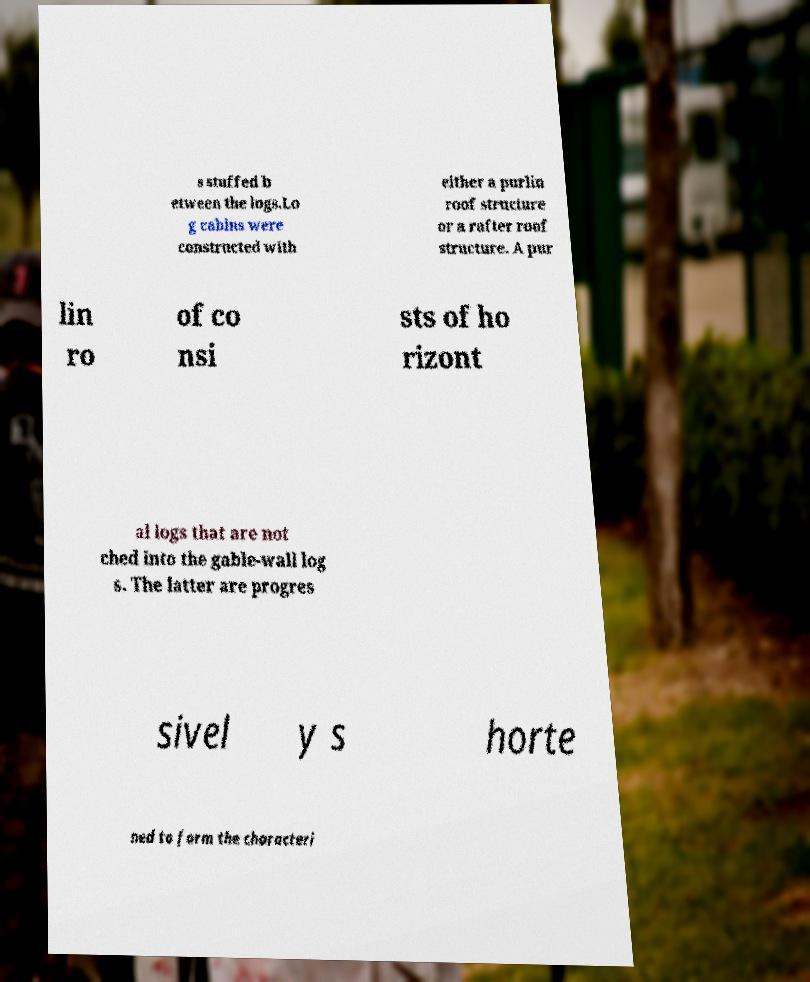Could you extract and type out the text from this image? s stuffed b etween the logs.Lo g cabins were constructed with either a purlin roof structure or a rafter roof structure. A pur lin ro of co nsi sts of ho rizont al logs that are not ched into the gable-wall log s. The latter are progres sivel y s horte ned to form the characteri 